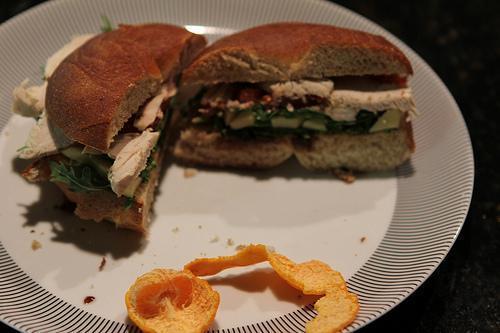How many slices of sandwich are there?
Give a very brief answer. 2. How many plates are there?
Give a very brief answer. 1. 